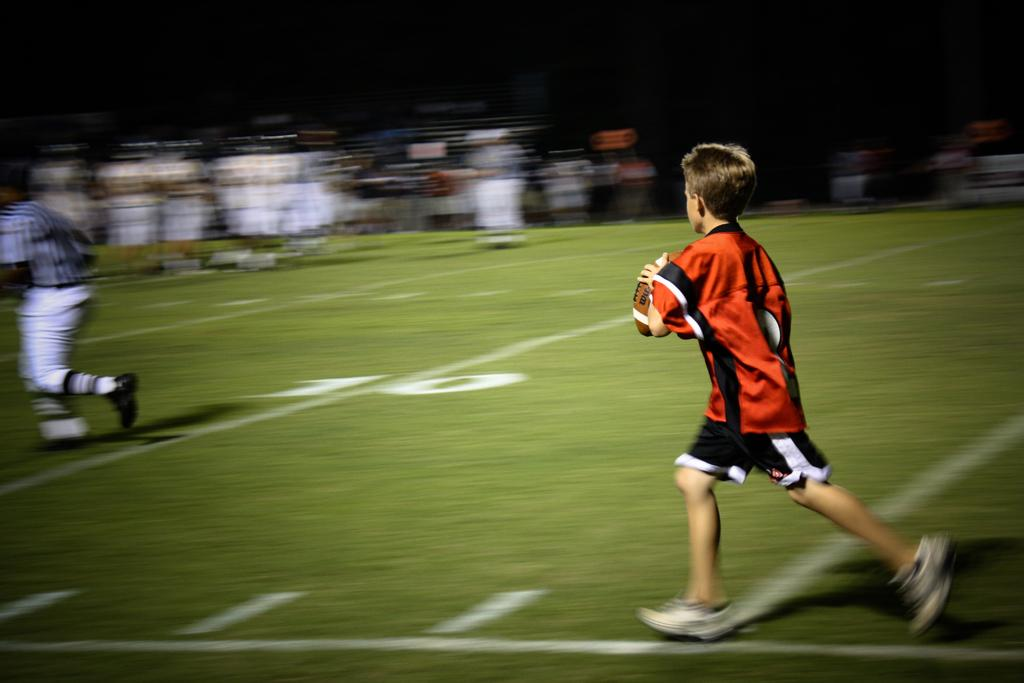What are the two persons in the image doing? The two persons in the image are running on the ground. What is one of the persons holding? One of the persons is holding a ball. Can you describe the background of the image? The background of the image is blurry. What type of laughter can be heard coming from the ground in the image? There is no laughter present in the image, as it features two persons running and holding a ball. 